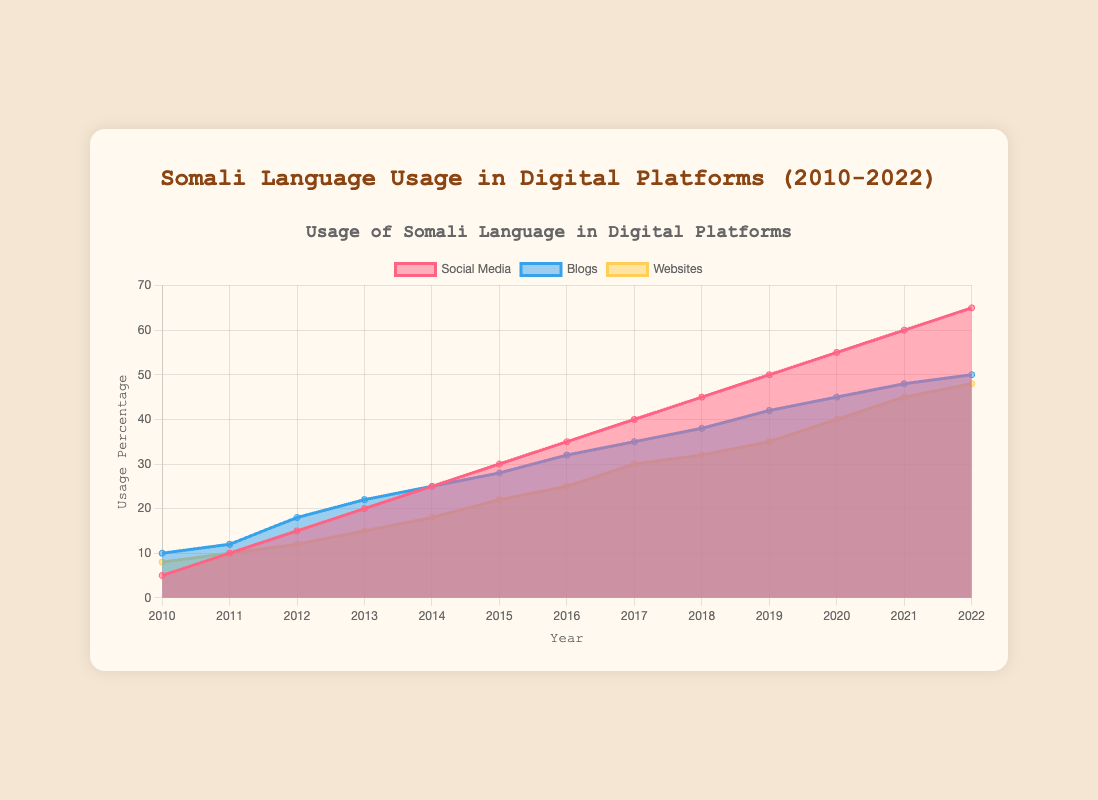What's the title of the chart? The title of the chart is prominently displayed at the top, indicating the main subject of the data. Look at the center top of the chart where it reads "Somali Language Usage in Digital Platforms (2010-2022)".
Answer: Somali Language Usage in Digital Platforms (2010-2022) How many different digital platforms are represented in the chart? By looking at the legend, you can see the three distinct colored areas representing different platforms. These are labeled as "Social Media," "Blogs," and "Websites."
Answer: 3 Which year had the highest usage of Somali language on social media? By examining the "Social Media" data line (the one represented by pinkish-red color), you can see that the maximum point is in the year 2022 with the value reaching the peak.
Answer: 2022 What is the difference in blog usage between 2012 and 2014? From the chart, note the "Blogs" usage in 2012 is 18% and in 2014 is 25%. Subtract the earlier value from the later one: 25 - 18.
Answer: 7 Between which consecutive years did the usage of Somali language on websites see the highest increase? Look at the "Websites" data (yellow color). Identify the years with the steepest slope. The highest increase occurs between 2015 (22%) and 2016 (25%).
Answer: 2015-2016 In which year did the usage of Somali language for blogs first surpass 30%? Trace the "Blogs" line (blue color) and see in 2016, the value reaches 32%, surpassing the 30% mark for the first time.
Answer: 2016 Compare the usage of Somali language on websites and blogs in the year 2015. Which was higher? Locate the values on the y-axis for both "Websites" and "Blogs" in 2015. "Websites" usage was 22% and "Blogs" usage was 28%. Thus, blogs were higher.
Answer: Blogs Which platform showed the most consistent increase in usage over the years? Observing all three lines, the "Social Media" line (pinkish-red color) consistently rises without any apparent dips from 2010 to 2022.
Answer: Social Media During which years did the usage of Somali language on social media grow by 10% or more compared to the previous year? Look at the "Social Media" values: between 2010 (5%) and 2011 (10%), between 2011 (10%) and 2012 (15%), between 2018 (45%) and 2019 (50%), between 2019 (50%) and 2020 (55%), and between 2020 (55%) and 2021 (60%) all show a growth of at least 10%.
Answer: 2010-2011, 2011-2012, 2018-2019, 2019-2020, 2020-2021 